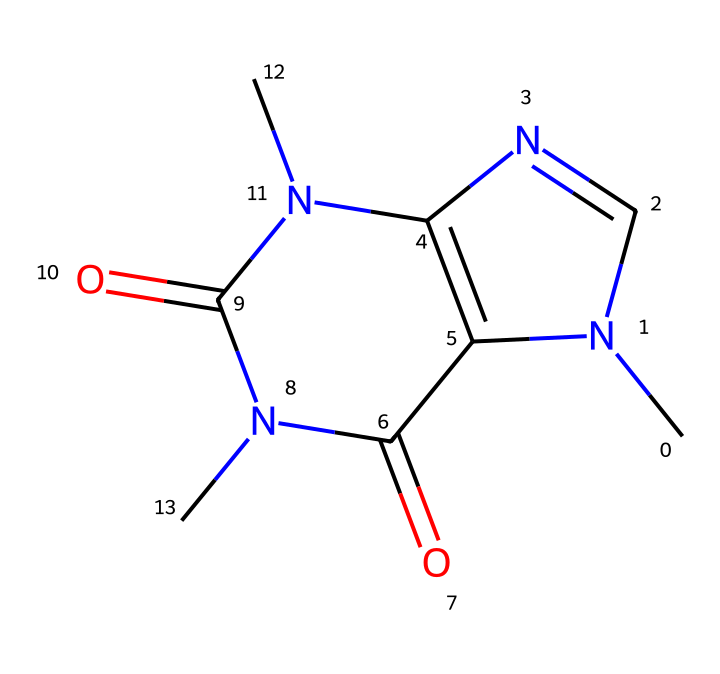What is the molecular formula of caffeine? By analyzing the chemical structure depicted in the SMILES notation, we can identify the constituent atoms. There are 8 carbon (C) atoms, 10 hydrogen (H) atoms, 4 nitrogen (N) atoms, and 2 oxygen (O) atoms. Therefore, the molecular formula is constructed as C8H10N4O2.
Answer: C8H10N4O2 How many rings are present in the caffeine structure? The SMILES representation indicates a bicyclic structure, which comprises two interconnected ring systems. Upon visual examination of the structure, we can confirm that there are two distinct rings in the caffeine molecule.
Answer: 2 What is the primary function of caffeine as a food additive? Caffeine acts primarily as a stimulant in food and beverages, enhancing alertness and reducing fatigue for consumers. It is widely recognized for this specific function in various canteen beverages, especially in settings like prisons.
Answer: stimulant How many nitrogen atoms are in the caffeine chemical structure? By scrutinizing the chemical structure represented in the SMILES string, we can count a total of four nitrogen (N) atoms in the molecule. This information is crucial, as it contributes to the overall properties and behaviors of caffeine.
Answer: 4 What type of bonding is present between the carbon and nitrogen in caffeine? The bonding between carbon and nitrogen in caffeine is primarily covalent. These bonds involve the sharing of electron pairs between the involved atoms, which is typical in organic compounds like caffeine.
Answer: covalent Why does caffeine exhibit its stimulant properties? Caffeine's stimulant properties can be attributed to its ability to block adenosine receptors in the brain. The resultant increase in neurotransmitters like dopamine and norepinephrine leads to heightened alertness. Structure-wise, the presence of nitrogen atoms in the ring structure plays a critical role in this activity.
Answer: adenosine receptors 